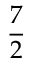<formula> <loc_0><loc_0><loc_500><loc_500>\frac { 7 } { 2 }</formula> 